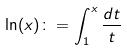Convert formula to latex. <formula><loc_0><loc_0><loc_500><loc_500>\ln ( x ) \colon = \int _ { 1 } ^ { x } \frac { d t } { t }</formula> 